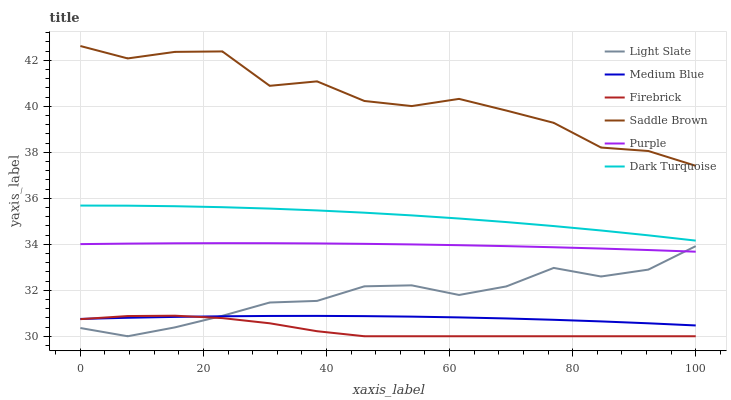Does Firebrick have the minimum area under the curve?
Answer yes or no. Yes. Does Saddle Brown have the maximum area under the curve?
Answer yes or no. Yes. Does Dark Turquoise have the minimum area under the curve?
Answer yes or no. No. Does Dark Turquoise have the maximum area under the curve?
Answer yes or no. No. Is Purple the smoothest?
Answer yes or no. Yes. Is Saddle Brown the roughest?
Answer yes or no. Yes. Is Dark Turquoise the smoothest?
Answer yes or no. No. Is Dark Turquoise the roughest?
Answer yes or no. No. Does Light Slate have the lowest value?
Answer yes or no. Yes. Does Dark Turquoise have the lowest value?
Answer yes or no. No. Does Saddle Brown have the highest value?
Answer yes or no. Yes. Does Dark Turquoise have the highest value?
Answer yes or no. No. Is Light Slate less than Saddle Brown?
Answer yes or no. Yes. Is Saddle Brown greater than Light Slate?
Answer yes or no. Yes. Does Light Slate intersect Purple?
Answer yes or no. Yes. Is Light Slate less than Purple?
Answer yes or no. No. Is Light Slate greater than Purple?
Answer yes or no. No. Does Light Slate intersect Saddle Brown?
Answer yes or no. No. 